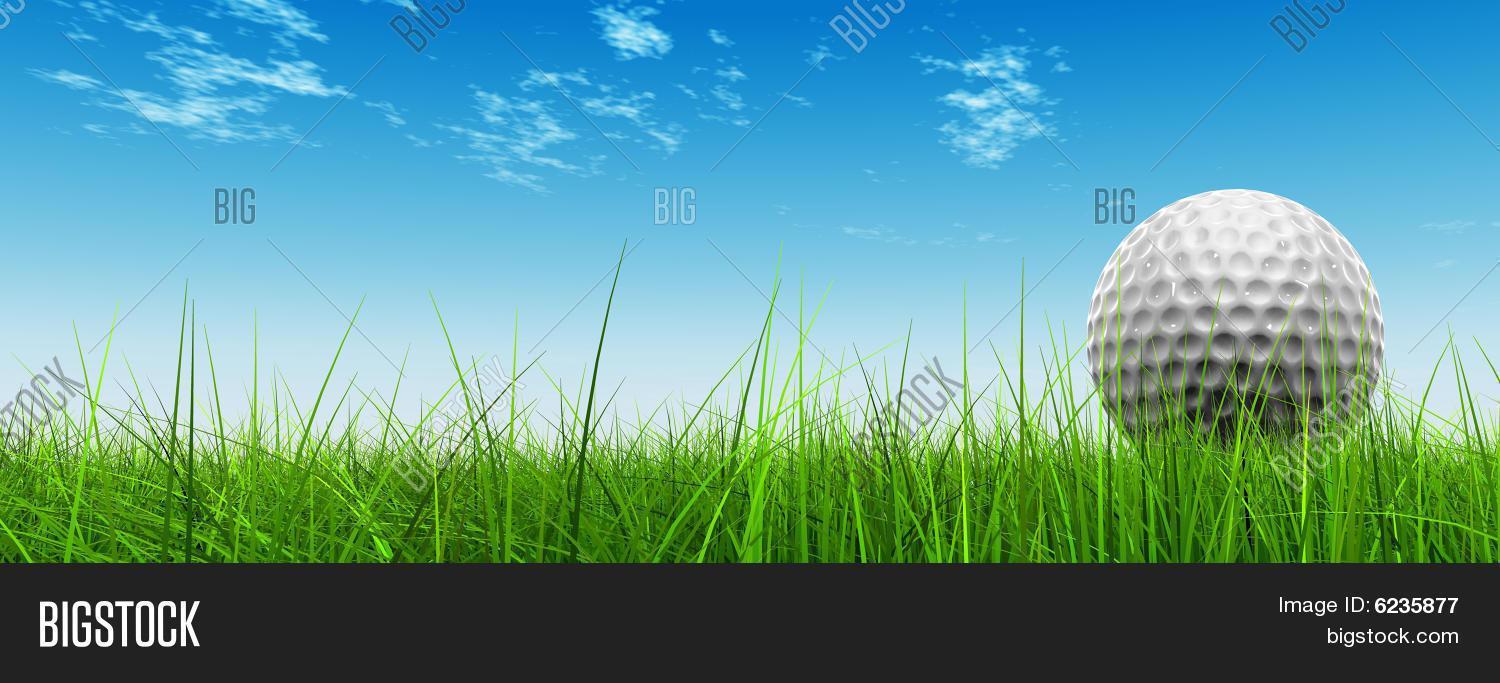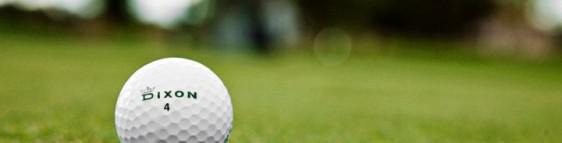The first image is the image on the left, the second image is the image on the right. Considering the images on both sides, is "At least one of the balls is sitting near the hole." valid? Answer yes or no. No. The first image is the image on the left, the second image is the image on the right. Evaluate the accuracy of this statement regarding the images: "A golf ball is on a tee in one image.". Is it true? Answer yes or no. No. 